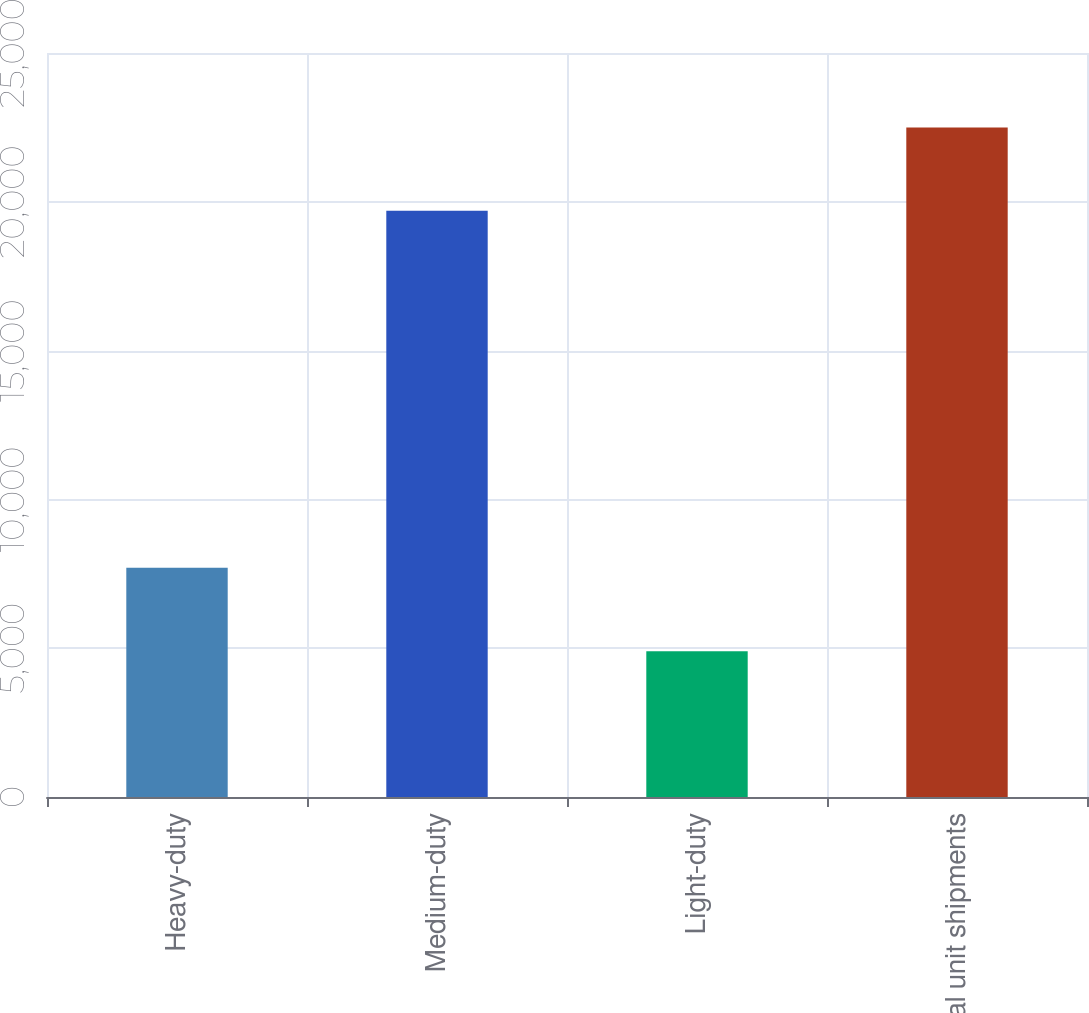<chart> <loc_0><loc_0><loc_500><loc_500><bar_chart><fcel>Heavy-duty<fcel>Medium-duty<fcel>Light-duty<fcel>Total unit shipments<nl><fcel>7700<fcel>19700<fcel>4900<fcel>22500<nl></chart> 